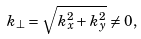Convert formula to latex. <formula><loc_0><loc_0><loc_500><loc_500>k _ { \perp } = \sqrt { k _ { x } ^ { 2 } + k _ { y } ^ { 2 } } \neq 0 ,</formula> 